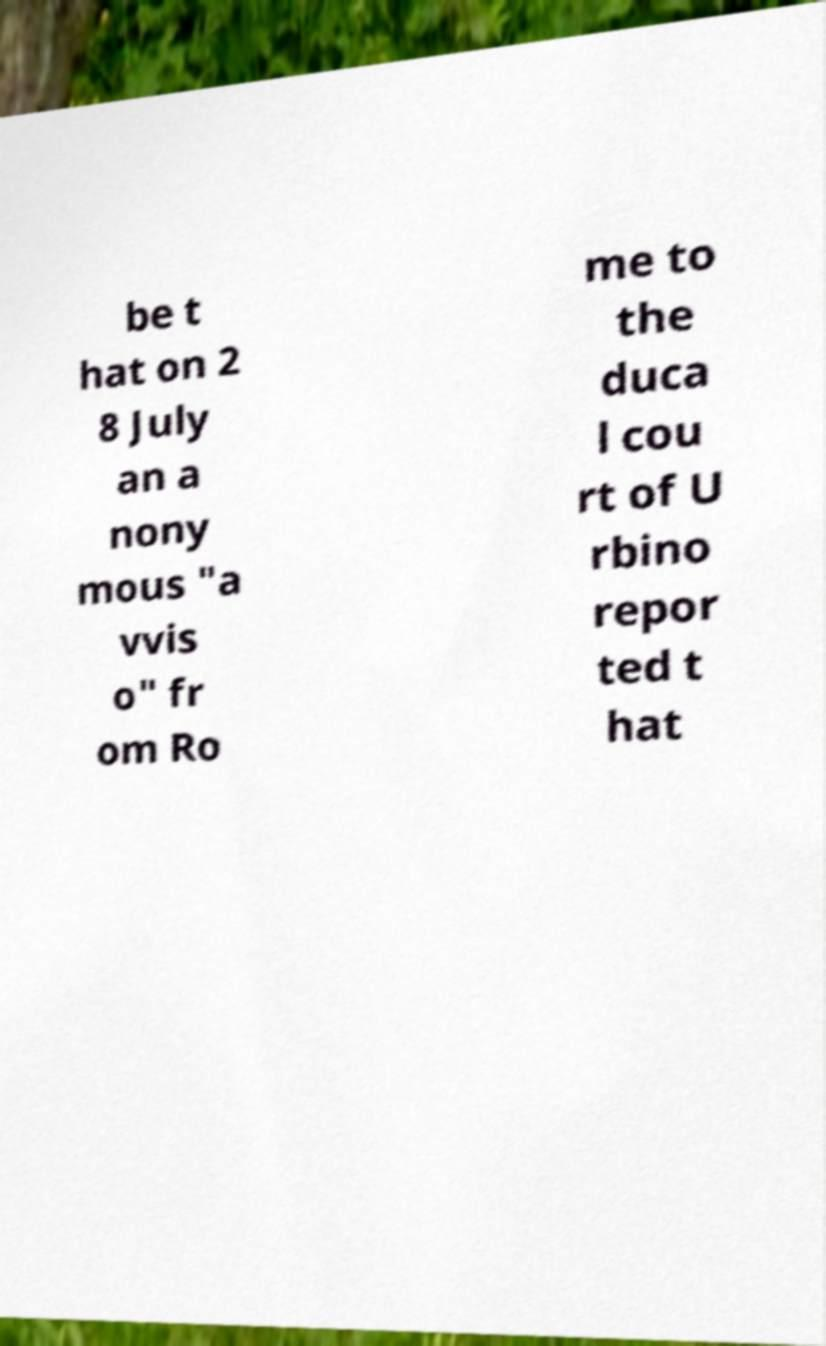Please read and relay the text visible in this image. What does it say? be t hat on 2 8 July an a nony mous "a vvis o" fr om Ro me to the duca l cou rt of U rbino repor ted t hat 